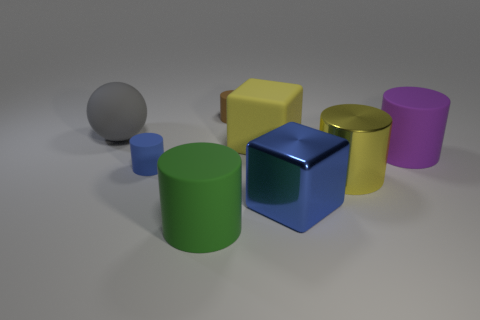Subtract all big green matte cylinders. How many cylinders are left? 4 Subtract 3 cylinders. How many cylinders are left? 2 Subtract all blue cylinders. How many cylinders are left? 4 Add 2 yellow metallic objects. How many objects exist? 10 Subtract all brown cylinders. Subtract all red balls. How many cylinders are left? 4 Subtract all balls. How many objects are left? 7 Subtract all small blue things. Subtract all large balls. How many objects are left? 6 Add 3 matte objects. How many matte objects are left? 9 Add 5 spheres. How many spheres exist? 6 Subtract 0 purple balls. How many objects are left? 8 